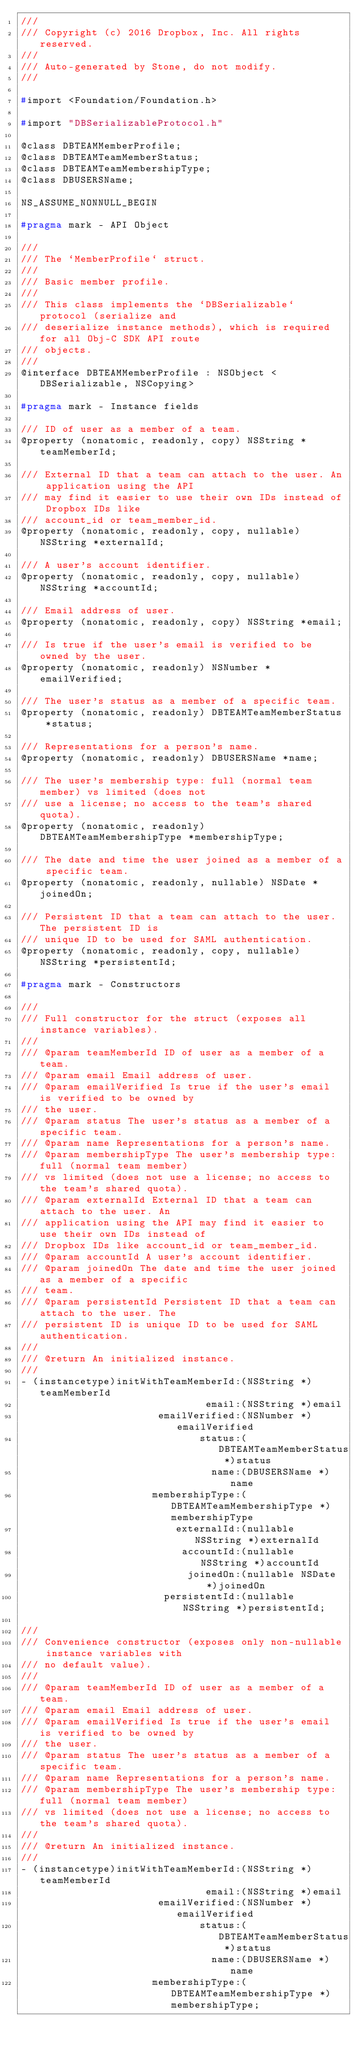<code> <loc_0><loc_0><loc_500><loc_500><_C_>///
/// Copyright (c) 2016 Dropbox, Inc. All rights reserved.
///
/// Auto-generated by Stone, do not modify.
///

#import <Foundation/Foundation.h>

#import "DBSerializableProtocol.h"

@class DBTEAMMemberProfile;
@class DBTEAMTeamMemberStatus;
@class DBTEAMTeamMembershipType;
@class DBUSERSName;

NS_ASSUME_NONNULL_BEGIN

#pragma mark - API Object

///
/// The `MemberProfile` struct.
///
/// Basic member profile.
///
/// This class implements the `DBSerializable` protocol (serialize and
/// deserialize instance methods), which is required for all Obj-C SDK API route
/// objects.
///
@interface DBTEAMMemberProfile : NSObject <DBSerializable, NSCopying>

#pragma mark - Instance fields

/// ID of user as a member of a team.
@property (nonatomic, readonly, copy) NSString *teamMemberId;

/// External ID that a team can attach to the user. An application using the API
/// may find it easier to use their own IDs instead of Dropbox IDs like
/// account_id or team_member_id.
@property (nonatomic, readonly, copy, nullable) NSString *externalId;

/// A user's account identifier.
@property (nonatomic, readonly, copy, nullable) NSString *accountId;

/// Email address of user.
@property (nonatomic, readonly, copy) NSString *email;

/// Is true if the user's email is verified to be owned by the user.
@property (nonatomic, readonly) NSNumber *emailVerified;

/// The user's status as a member of a specific team.
@property (nonatomic, readonly) DBTEAMTeamMemberStatus *status;

/// Representations for a person's name.
@property (nonatomic, readonly) DBUSERSName *name;

/// The user's membership type: full (normal team member) vs limited (does not
/// use a license; no access to the team's shared quota).
@property (nonatomic, readonly) DBTEAMTeamMembershipType *membershipType;

/// The date and time the user joined as a member of a specific team.
@property (nonatomic, readonly, nullable) NSDate *joinedOn;

/// Persistent ID that a team can attach to the user. The persistent ID is
/// unique ID to be used for SAML authentication.
@property (nonatomic, readonly, copy, nullable) NSString *persistentId;

#pragma mark - Constructors

///
/// Full constructor for the struct (exposes all instance variables).
///
/// @param teamMemberId ID of user as a member of a team.
/// @param email Email address of user.
/// @param emailVerified Is true if the user's email is verified to be owned by
/// the user.
/// @param status The user's status as a member of a specific team.
/// @param name Representations for a person's name.
/// @param membershipType The user's membership type: full (normal team member)
/// vs limited (does not use a license; no access to the team's shared quota).
/// @param externalId External ID that a team can attach to the user. An
/// application using the API may find it easier to use their own IDs instead of
/// Dropbox IDs like account_id or team_member_id.
/// @param accountId A user's account identifier.
/// @param joinedOn The date and time the user joined as a member of a specific
/// team.
/// @param persistentId Persistent ID that a team can attach to the user. The
/// persistent ID is unique ID to be used for SAML authentication.
///
/// @return An initialized instance.
///
- (instancetype)initWithTeamMemberId:(NSString *)teamMemberId
                               email:(NSString *)email
                       emailVerified:(NSNumber *)emailVerified
                              status:(DBTEAMTeamMemberStatus *)status
                                name:(DBUSERSName *)name
                      membershipType:(DBTEAMTeamMembershipType *)membershipType
                          externalId:(nullable NSString *)externalId
                           accountId:(nullable NSString *)accountId
                            joinedOn:(nullable NSDate *)joinedOn
                        persistentId:(nullable NSString *)persistentId;

///
/// Convenience constructor (exposes only non-nullable instance variables with
/// no default value).
///
/// @param teamMemberId ID of user as a member of a team.
/// @param email Email address of user.
/// @param emailVerified Is true if the user's email is verified to be owned by
/// the user.
/// @param status The user's status as a member of a specific team.
/// @param name Representations for a person's name.
/// @param membershipType The user's membership type: full (normal team member)
/// vs limited (does not use a license; no access to the team's shared quota).
///
/// @return An initialized instance.
///
- (instancetype)initWithTeamMemberId:(NSString *)teamMemberId
                               email:(NSString *)email
                       emailVerified:(NSNumber *)emailVerified
                              status:(DBTEAMTeamMemberStatus *)status
                                name:(DBUSERSName *)name
                      membershipType:(DBTEAMTeamMembershipType *)membershipType;
</code> 